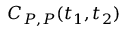<formula> <loc_0><loc_0><loc_500><loc_500>C _ { P , P } ( t _ { 1 } , t _ { 2 } )</formula> 